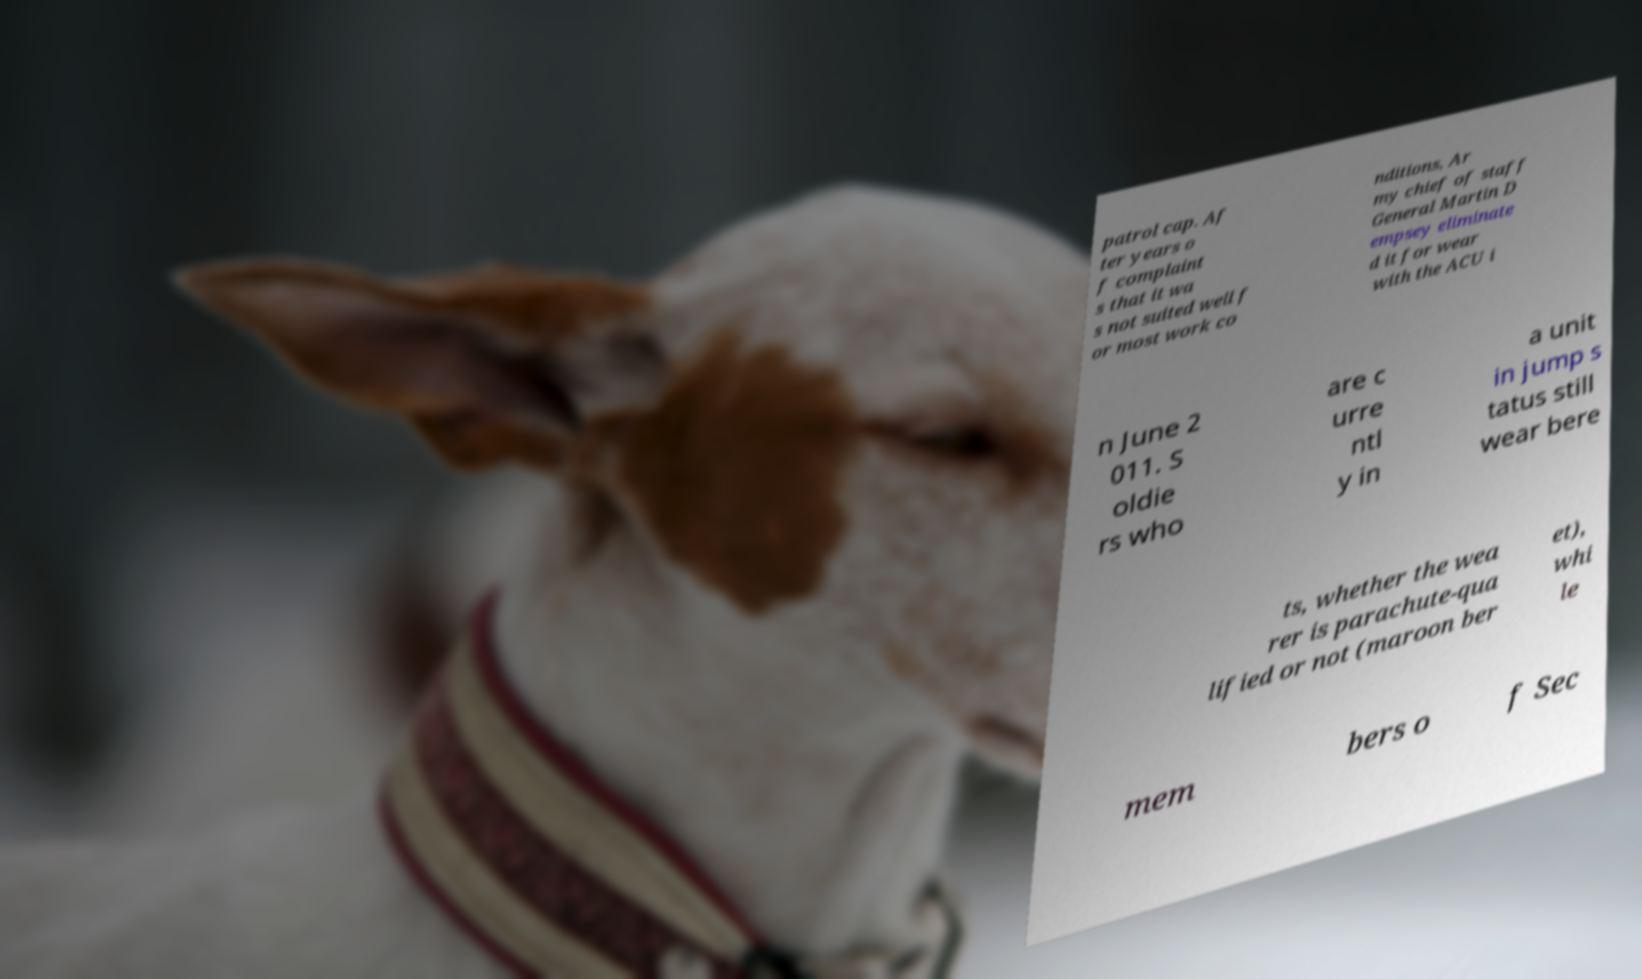For documentation purposes, I need the text within this image transcribed. Could you provide that? patrol cap. Af ter years o f complaint s that it wa s not suited well f or most work co nditions, Ar my chief of staff General Martin D empsey eliminate d it for wear with the ACU i n June 2 011. S oldie rs who are c urre ntl y in a unit in jump s tatus still wear bere ts, whether the wea rer is parachute-qua lified or not (maroon ber et), whi le mem bers o f Sec 